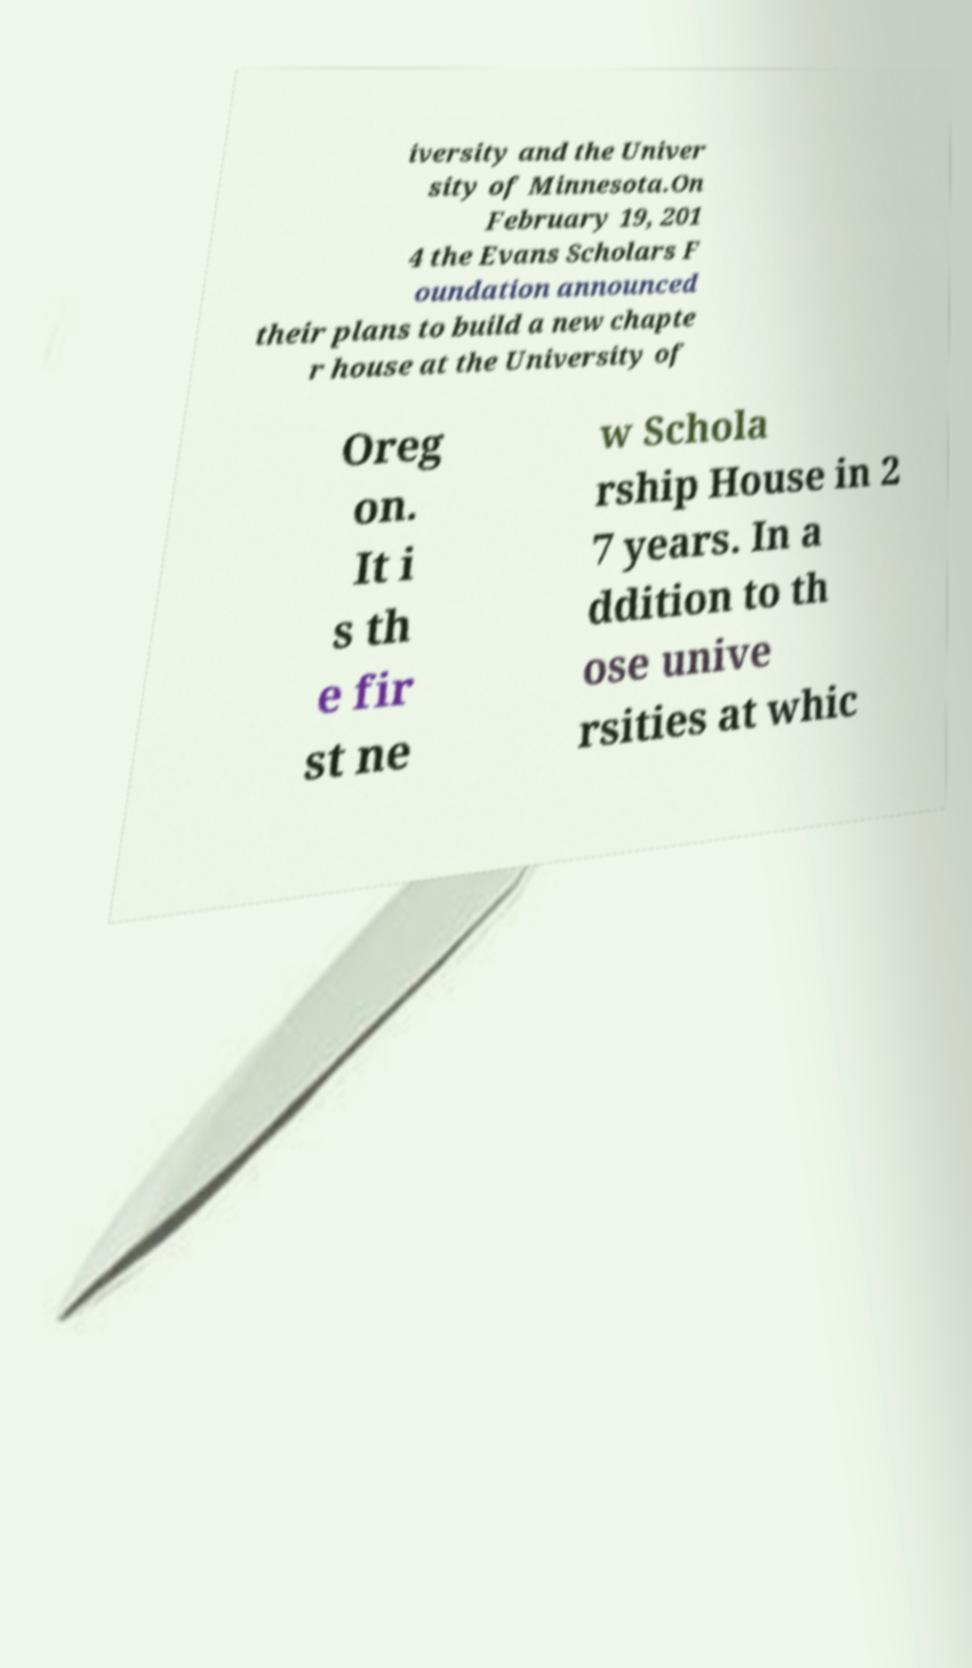Please read and relay the text visible in this image. What does it say? iversity and the Univer sity of Minnesota.On February 19, 201 4 the Evans Scholars F oundation announced their plans to build a new chapte r house at the University of Oreg on. It i s th e fir st ne w Schola rship House in 2 7 years. In a ddition to th ose unive rsities at whic 